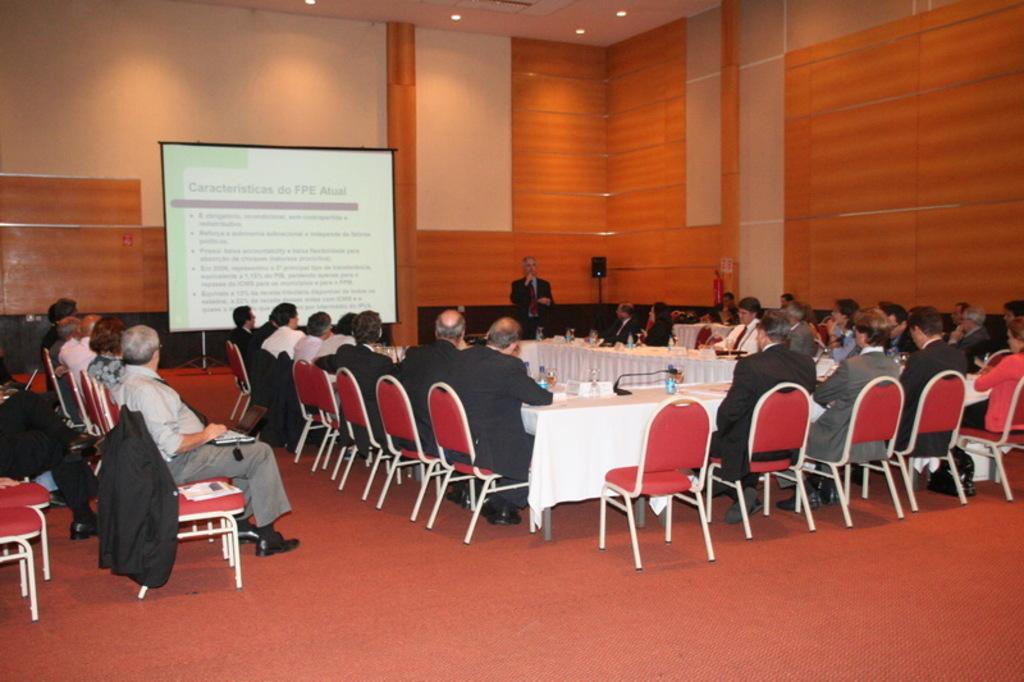Describe this image in one or two sentences. This is a picture of a meeting. In the background there is a screen. In the center of the image there are lot of people seated in chair. There is a desk on the desk their bottles papers and mic. Floor is covered with mat. 